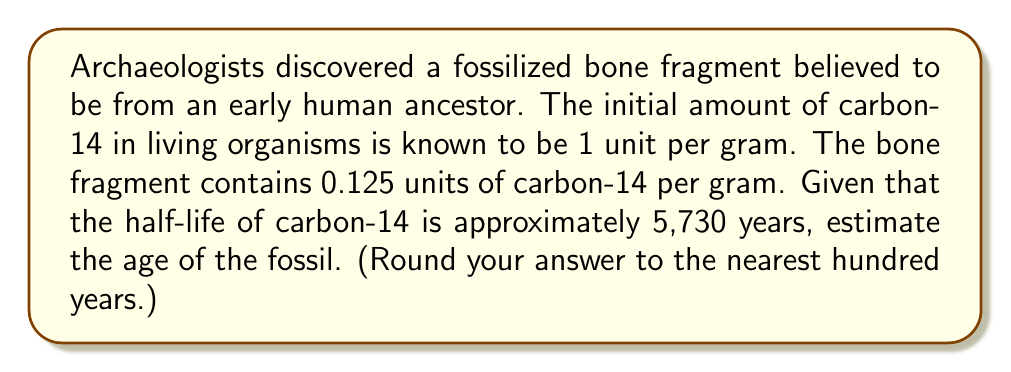Could you help me with this problem? Let's approach this step-by-step:

1) The exponential decay formula is:
   $$A(t) = A_0 \cdot (1/2)^{t/t_{1/2}}$$
   where:
   $A(t)$ is the amount remaining after time $t$
   $A_0$ is the initial amount
   $t$ is the time elapsed
   $t_{1/2}$ is the half-life

2) We know:
   $A_0 = 1$ unit/gram (initial amount)
   $A(t) = 0.125$ units/gram (amount remaining)
   $t_{1/2} = 5,730$ years (half-life of carbon-14)

3) Let's substitute these values into the formula:
   $$0.125 = 1 \cdot (1/2)^{t/5730}$$

4) Simplify:
   $$0.125 = (1/2)^{t/5730}$$

5) Take the natural log of both sides:
   $$\ln(0.125) = \ln((1/2)^{t/5730})$$

6) Use the logarithm property $\ln(a^b) = b\ln(a)$:
   $$\ln(0.125) = (t/5730) \cdot \ln(1/2)$$

7) Solve for $t$:
   $$t = 5730 \cdot \frac{\ln(0.125)}{\ln(1/2)}$$

8) Calculate:
   $$t \approx 17,190 \text{ years}$$

9) Rounding to the nearest hundred years:
   $$t \approx 17,200 \text{ years}$$
Answer: 17,200 years 